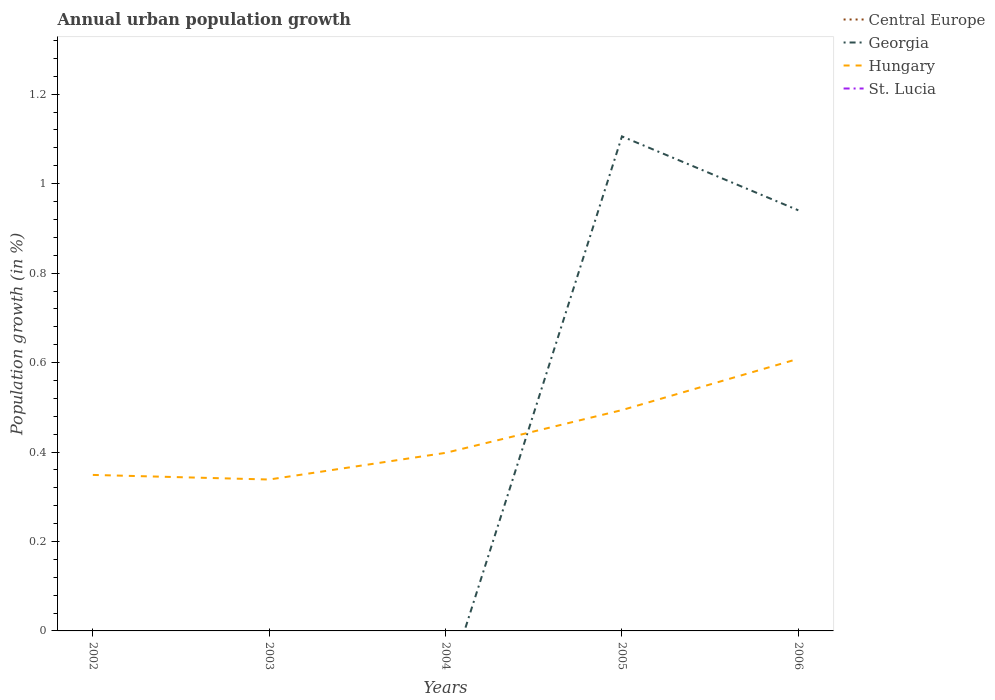How many different coloured lines are there?
Your answer should be very brief. 2. Does the line corresponding to Georgia intersect with the line corresponding to Hungary?
Offer a terse response. Yes. Is the number of lines equal to the number of legend labels?
Make the answer very short. No. Across all years, what is the maximum percentage of urban population growth in St. Lucia?
Make the answer very short. 0. What is the total percentage of urban population growth in Hungary in the graph?
Ensure brevity in your answer.  -0.26. What is the difference between the highest and the second highest percentage of urban population growth in Georgia?
Keep it short and to the point. 1.11. What is the difference between the highest and the lowest percentage of urban population growth in Georgia?
Offer a terse response. 2. Is the percentage of urban population growth in St. Lucia strictly greater than the percentage of urban population growth in Georgia over the years?
Your response must be concise. Yes. How many lines are there?
Make the answer very short. 2. What is the difference between two consecutive major ticks on the Y-axis?
Your answer should be very brief. 0.2. Does the graph contain any zero values?
Offer a very short reply. Yes. Does the graph contain grids?
Keep it short and to the point. No. How many legend labels are there?
Offer a terse response. 4. What is the title of the graph?
Your response must be concise. Annual urban population growth. Does "Maldives" appear as one of the legend labels in the graph?
Offer a terse response. No. What is the label or title of the Y-axis?
Your response must be concise. Population growth (in %). What is the Population growth (in %) in Georgia in 2002?
Keep it short and to the point. 0. What is the Population growth (in %) in Hungary in 2002?
Your answer should be very brief. 0.35. What is the Population growth (in %) in Central Europe in 2003?
Offer a terse response. 0. What is the Population growth (in %) of Hungary in 2003?
Your answer should be compact. 0.34. What is the Population growth (in %) of St. Lucia in 2003?
Keep it short and to the point. 0. What is the Population growth (in %) of Central Europe in 2004?
Provide a succinct answer. 0. What is the Population growth (in %) in Georgia in 2004?
Your answer should be very brief. 0. What is the Population growth (in %) of Hungary in 2004?
Provide a succinct answer. 0.4. What is the Population growth (in %) in Central Europe in 2005?
Offer a very short reply. 0. What is the Population growth (in %) in Georgia in 2005?
Offer a very short reply. 1.11. What is the Population growth (in %) of Hungary in 2005?
Your response must be concise. 0.49. What is the Population growth (in %) of St. Lucia in 2005?
Your answer should be very brief. 0. What is the Population growth (in %) of Central Europe in 2006?
Your answer should be compact. 0. What is the Population growth (in %) in Georgia in 2006?
Your answer should be compact. 0.94. What is the Population growth (in %) of Hungary in 2006?
Provide a succinct answer. 0.61. What is the Population growth (in %) of St. Lucia in 2006?
Ensure brevity in your answer.  0. Across all years, what is the maximum Population growth (in %) in Georgia?
Ensure brevity in your answer.  1.11. Across all years, what is the maximum Population growth (in %) of Hungary?
Offer a terse response. 0.61. Across all years, what is the minimum Population growth (in %) of Hungary?
Make the answer very short. 0.34. What is the total Population growth (in %) of Georgia in the graph?
Your answer should be very brief. 2.05. What is the total Population growth (in %) of Hungary in the graph?
Ensure brevity in your answer.  2.19. What is the difference between the Population growth (in %) of Hungary in 2002 and that in 2003?
Provide a short and direct response. 0.01. What is the difference between the Population growth (in %) in Hungary in 2002 and that in 2004?
Provide a short and direct response. -0.05. What is the difference between the Population growth (in %) of Hungary in 2002 and that in 2005?
Give a very brief answer. -0.14. What is the difference between the Population growth (in %) of Hungary in 2002 and that in 2006?
Your response must be concise. -0.26. What is the difference between the Population growth (in %) in Hungary in 2003 and that in 2004?
Give a very brief answer. -0.06. What is the difference between the Population growth (in %) in Hungary in 2003 and that in 2005?
Make the answer very short. -0.16. What is the difference between the Population growth (in %) in Hungary in 2003 and that in 2006?
Provide a succinct answer. -0.27. What is the difference between the Population growth (in %) of Hungary in 2004 and that in 2005?
Ensure brevity in your answer.  -0.1. What is the difference between the Population growth (in %) in Hungary in 2004 and that in 2006?
Make the answer very short. -0.21. What is the difference between the Population growth (in %) in Georgia in 2005 and that in 2006?
Keep it short and to the point. 0.17. What is the difference between the Population growth (in %) of Hungary in 2005 and that in 2006?
Ensure brevity in your answer.  -0.11. What is the difference between the Population growth (in %) of Georgia in 2005 and the Population growth (in %) of Hungary in 2006?
Your answer should be very brief. 0.5. What is the average Population growth (in %) of Central Europe per year?
Provide a short and direct response. 0. What is the average Population growth (in %) of Georgia per year?
Your answer should be very brief. 0.41. What is the average Population growth (in %) of Hungary per year?
Make the answer very short. 0.44. In the year 2005, what is the difference between the Population growth (in %) in Georgia and Population growth (in %) in Hungary?
Make the answer very short. 0.61. In the year 2006, what is the difference between the Population growth (in %) of Georgia and Population growth (in %) of Hungary?
Your answer should be very brief. 0.33. What is the ratio of the Population growth (in %) in Hungary in 2002 to that in 2003?
Your response must be concise. 1.03. What is the ratio of the Population growth (in %) in Hungary in 2002 to that in 2004?
Provide a succinct answer. 0.88. What is the ratio of the Population growth (in %) in Hungary in 2002 to that in 2005?
Provide a succinct answer. 0.71. What is the ratio of the Population growth (in %) of Hungary in 2002 to that in 2006?
Your response must be concise. 0.57. What is the ratio of the Population growth (in %) of Hungary in 2003 to that in 2004?
Ensure brevity in your answer.  0.85. What is the ratio of the Population growth (in %) in Hungary in 2003 to that in 2005?
Provide a succinct answer. 0.69. What is the ratio of the Population growth (in %) in Hungary in 2003 to that in 2006?
Your answer should be compact. 0.56. What is the ratio of the Population growth (in %) of Hungary in 2004 to that in 2005?
Offer a terse response. 0.81. What is the ratio of the Population growth (in %) in Hungary in 2004 to that in 2006?
Offer a terse response. 0.65. What is the ratio of the Population growth (in %) of Georgia in 2005 to that in 2006?
Offer a very short reply. 1.18. What is the ratio of the Population growth (in %) in Hungary in 2005 to that in 2006?
Your response must be concise. 0.81. What is the difference between the highest and the second highest Population growth (in %) of Hungary?
Offer a terse response. 0.11. What is the difference between the highest and the lowest Population growth (in %) of Georgia?
Offer a terse response. 1.11. What is the difference between the highest and the lowest Population growth (in %) in Hungary?
Your answer should be compact. 0.27. 